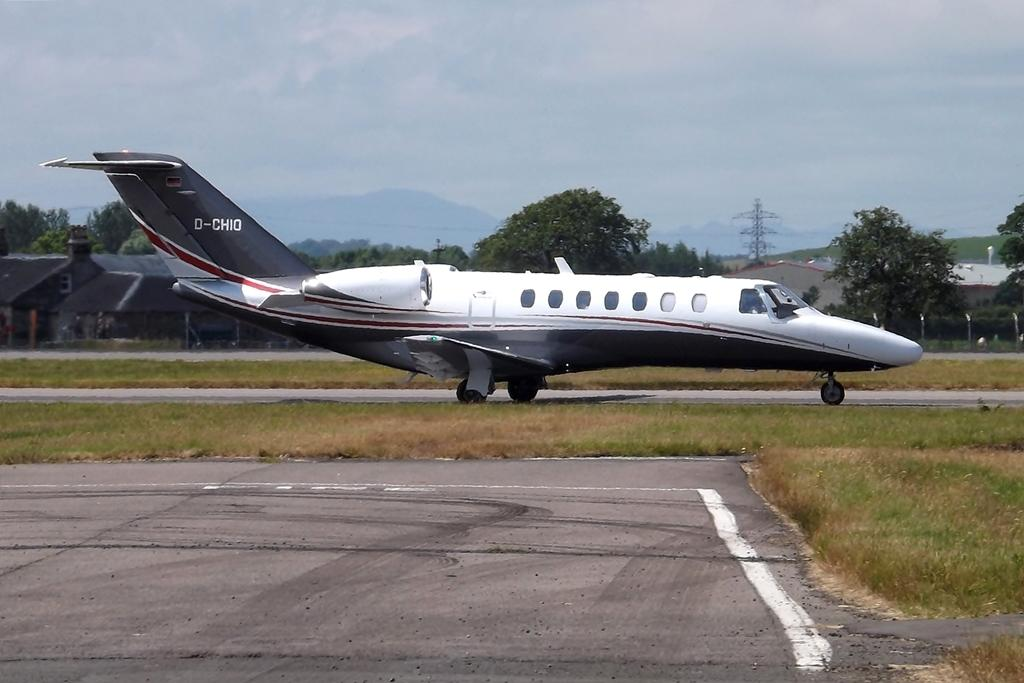<image>
Write a terse but informative summary of the picture. A jet is taxiing down the runway with the tail number D-CHIO. 